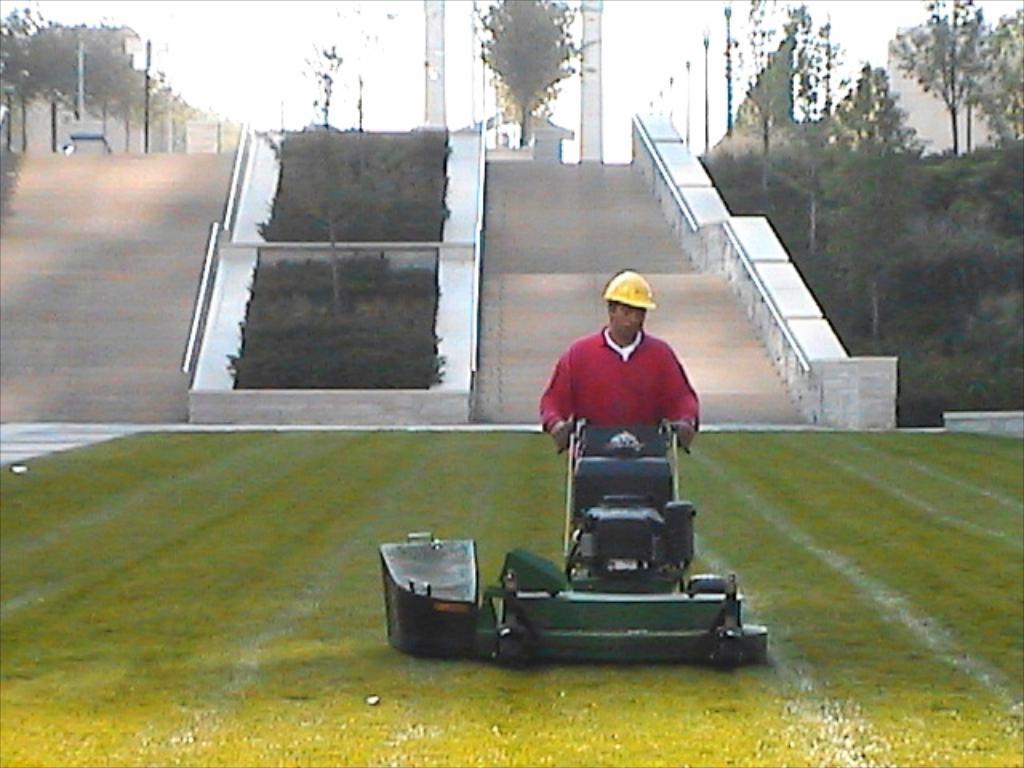How would you summarize this image in a sentence or two? In this picture I can see a man holding a grass cutting machine and I can see trees and stairs and I can see a man wore a cap on his head and I can see a cloudy sky. 